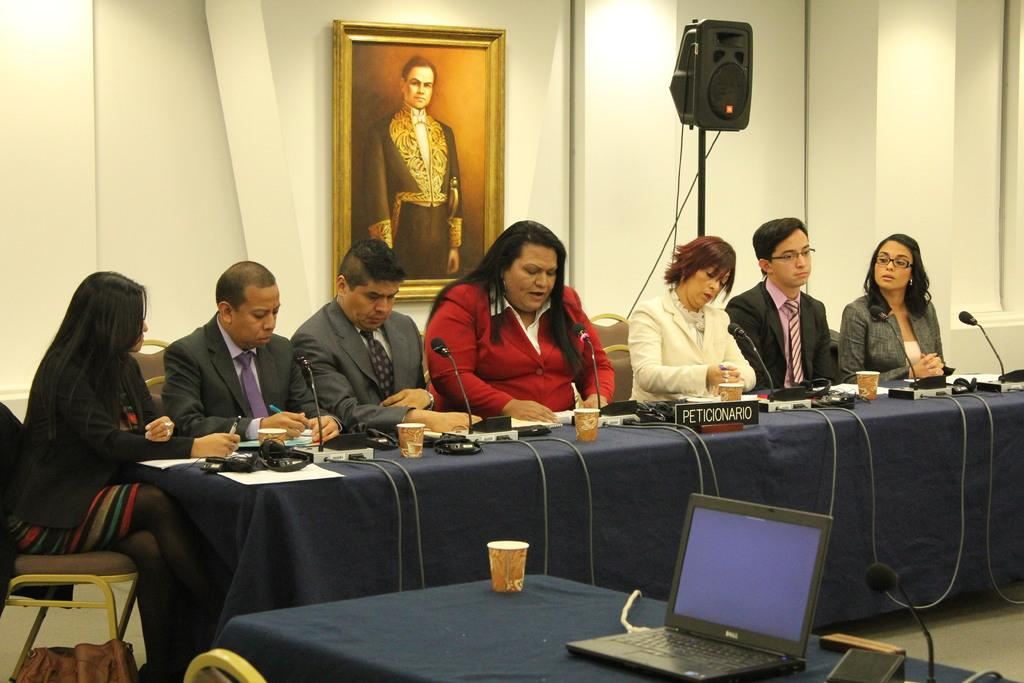<image>
Offer a succinct explanation of the picture presented. the word Dell that is on a laptop computer 